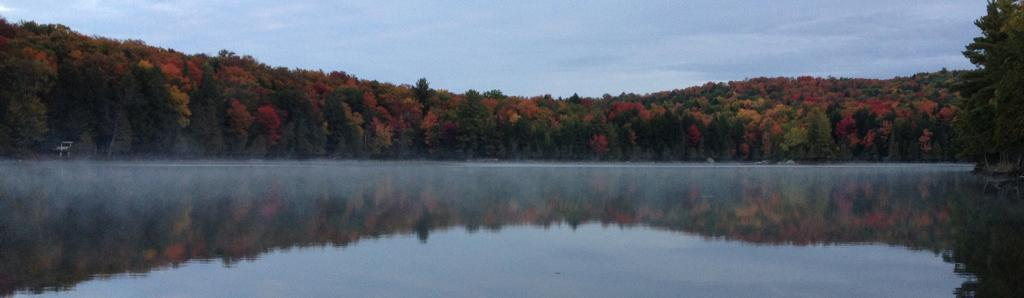What type of natural feature is at the bottom of the image? There is a river at the bottom of the image. What can be seen in the background of the image? There are trees in the background of the image. What is visible at the top of the image? The sky is visible at the top of the image. What type of quince dish is being served in the image? There is no quince dish present in the image; it features a river, trees, and the sky. What type of soup is being prepared in the image? There is no soup being prepared in the image; it features a river, trees, and the sky. 